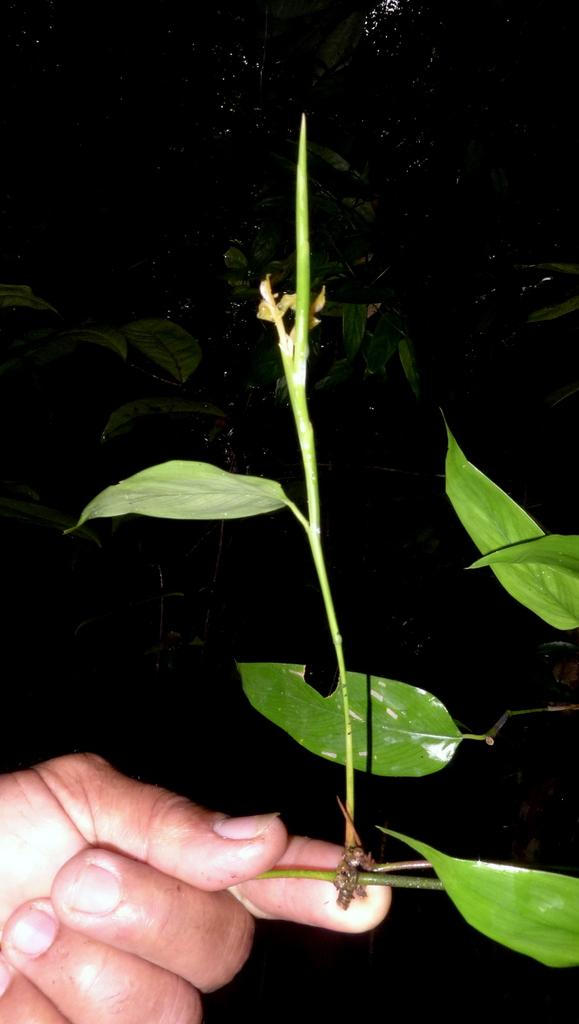What is the person on the left side of the image holding? The person is holding a plant on the left side of the image. What can be observed about the plant's appearance? The plant has green leaves. How would you describe the overall color scheme of the image? The background of the image is dark in color. What type of underwear is the person wearing in the image? There is no information about the person's underwear in the image, so it cannot be determined. 